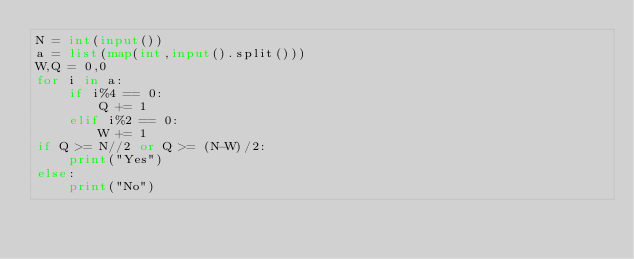<code> <loc_0><loc_0><loc_500><loc_500><_Python_>N = int(input())
a = list(map(int,input().split()))
W,Q = 0,0 
for i in a:
    if i%4 == 0:
        Q += 1
    elif i%2 == 0:
        W += 1
if Q >= N//2 or Q >= (N-W)/2:
    print("Yes")
else:
    print("No")</code> 